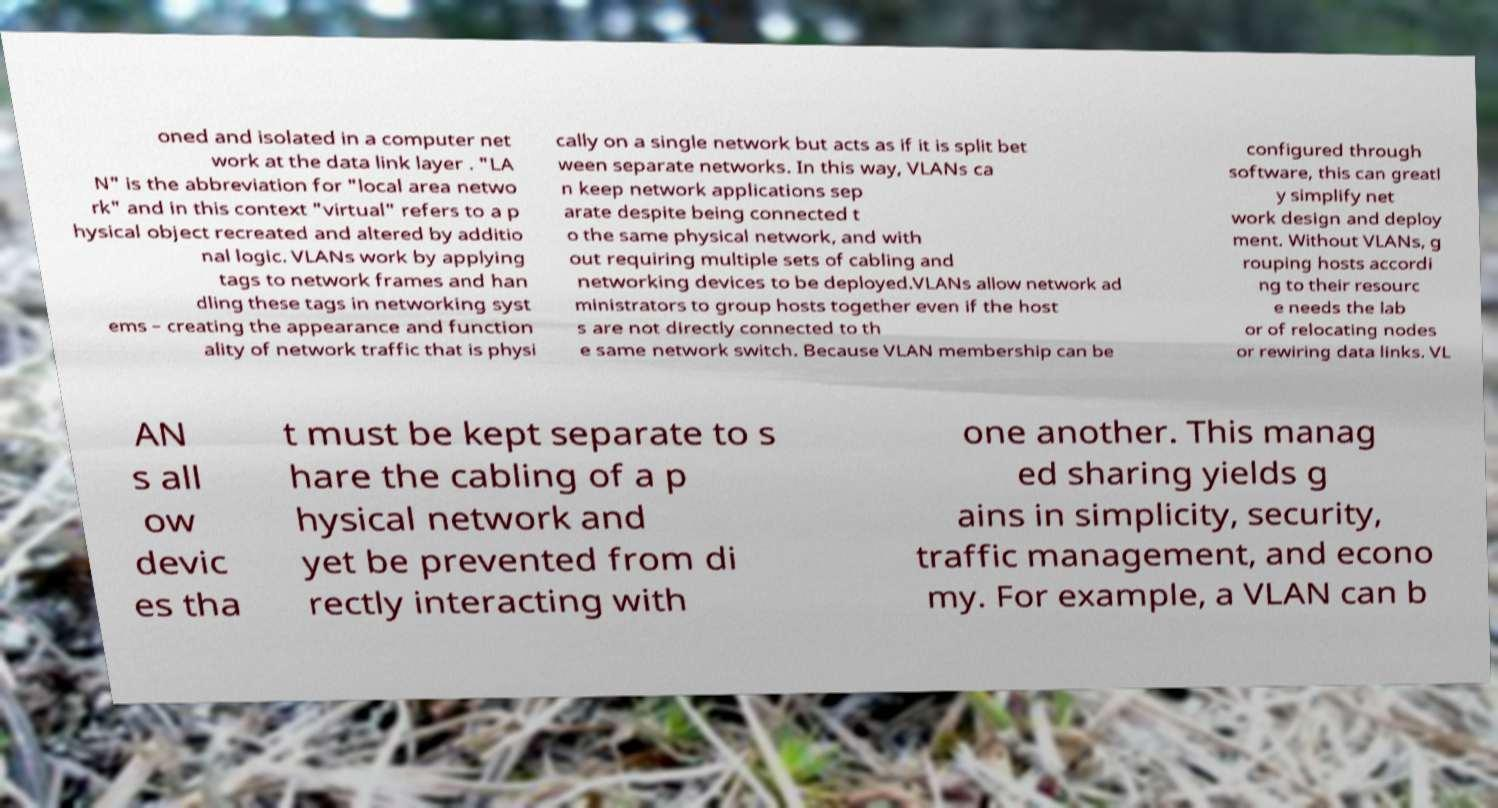What messages or text are displayed in this image? I need them in a readable, typed format. oned and isolated in a computer net work at the data link layer . "LA N" is the abbreviation for "local area netwo rk" and in this context "virtual" refers to a p hysical object recreated and altered by additio nal logic. VLANs work by applying tags to network frames and han dling these tags in networking syst ems – creating the appearance and function ality of network traffic that is physi cally on a single network but acts as if it is split bet ween separate networks. In this way, VLANs ca n keep network applications sep arate despite being connected t o the same physical network, and with out requiring multiple sets of cabling and networking devices to be deployed.VLANs allow network ad ministrators to group hosts together even if the host s are not directly connected to th e same network switch. Because VLAN membership can be configured through software, this can greatl y simplify net work design and deploy ment. Without VLANs, g rouping hosts accordi ng to their resourc e needs the lab or of relocating nodes or rewiring data links. VL AN s all ow devic es tha t must be kept separate to s hare the cabling of a p hysical network and yet be prevented from di rectly interacting with one another. This manag ed sharing yields g ains in simplicity, security, traffic management, and econo my. For example, a VLAN can b 